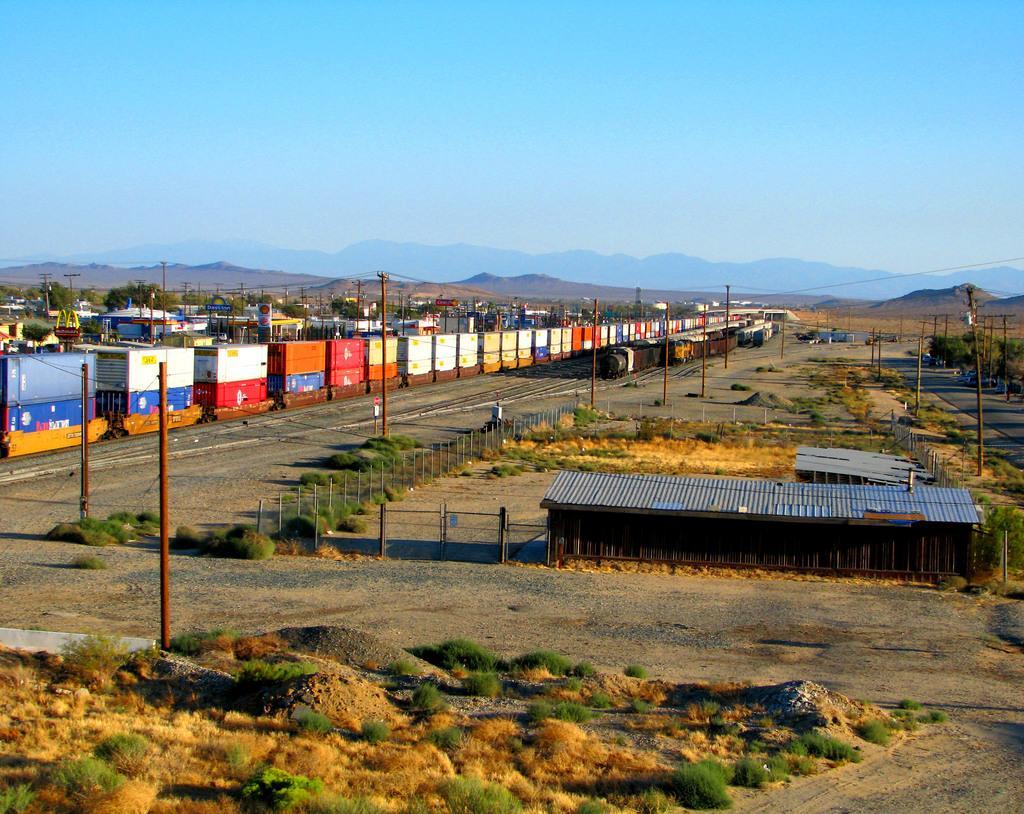Can you describe this image briefly? In the middle there are railway tracks and trains. This is the iron shirt, at the top it is the sky. 